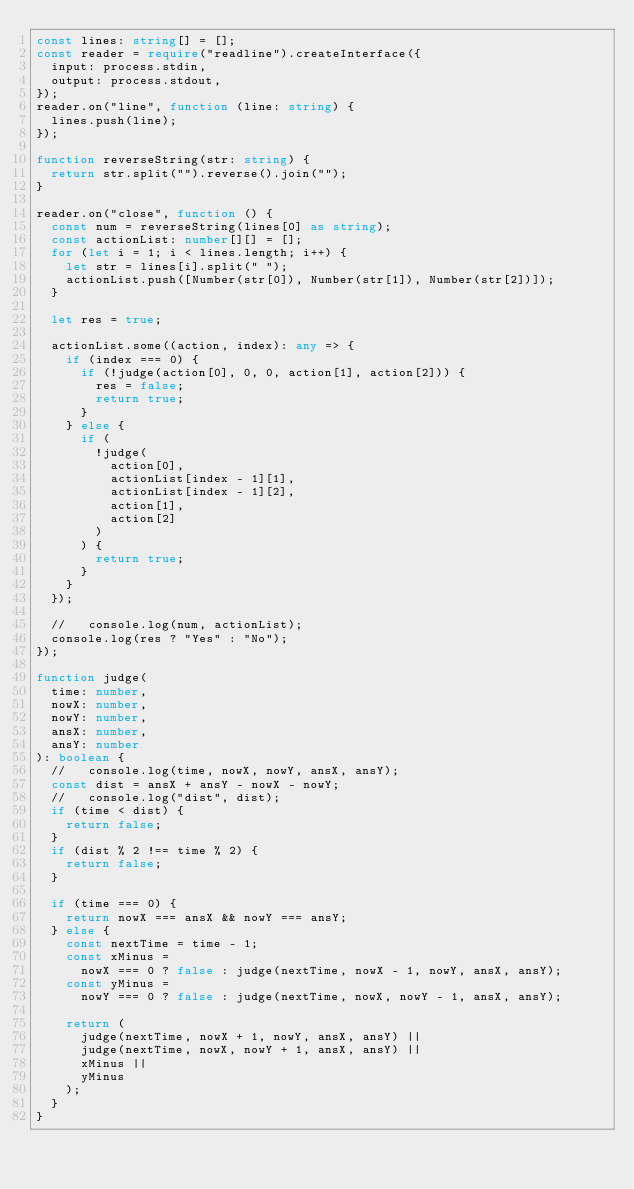Convert code to text. <code><loc_0><loc_0><loc_500><loc_500><_TypeScript_>const lines: string[] = [];
const reader = require("readline").createInterface({
  input: process.stdin,
  output: process.stdout,
});
reader.on("line", function (line: string) {
  lines.push(line);
});

function reverseString(str: string) {
  return str.split("").reverse().join("");
}

reader.on("close", function () {
  const num = reverseString(lines[0] as string);
  const actionList: number[][] = [];
  for (let i = 1; i < lines.length; i++) {
    let str = lines[i].split(" ");
    actionList.push([Number(str[0]), Number(str[1]), Number(str[2])]);
  }

  let res = true;

  actionList.some((action, index): any => {
    if (index === 0) {
      if (!judge(action[0], 0, 0, action[1], action[2])) {
        res = false;
        return true;
      }
    } else {
      if (
        !judge(
          action[0],
          actionList[index - 1][1],
          actionList[index - 1][2],
          action[1],
          action[2]
        )
      ) {
        return true;
      }
    }
  });

  //   console.log(num, actionList);
  console.log(res ? "Yes" : "No");
});

function judge(
  time: number,
  nowX: number,
  nowY: number,
  ansX: number,
  ansY: number
): boolean {
  //   console.log(time, nowX, nowY, ansX, ansY);
  const dist = ansX + ansY - nowX - nowY;
  //   console.log("dist", dist);
  if (time < dist) {
    return false;
  }
  if (dist % 2 !== time % 2) {
    return false;
  }

  if (time === 0) {
    return nowX === ansX && nowY === ansY;
  } else {
    const nextTime = time - 1;
    const xMinus =
      nowX === 0 ? false : judge(nextTime, nowX - 1, nowY, ansX, ansY);
    const yMinus =
      nowY === 0 ? false : judge(nextTime, nowX, nowY - 1, ansX, ansY);

    return (
      judge(nextTime, nowX + 1, nowY, ansX, ansY) ||
      judge(nextTime, nowX, nowY + 1, ansX, ansY) ||
      xMinus ||
      yMinus
    );
  }
}
</code> 